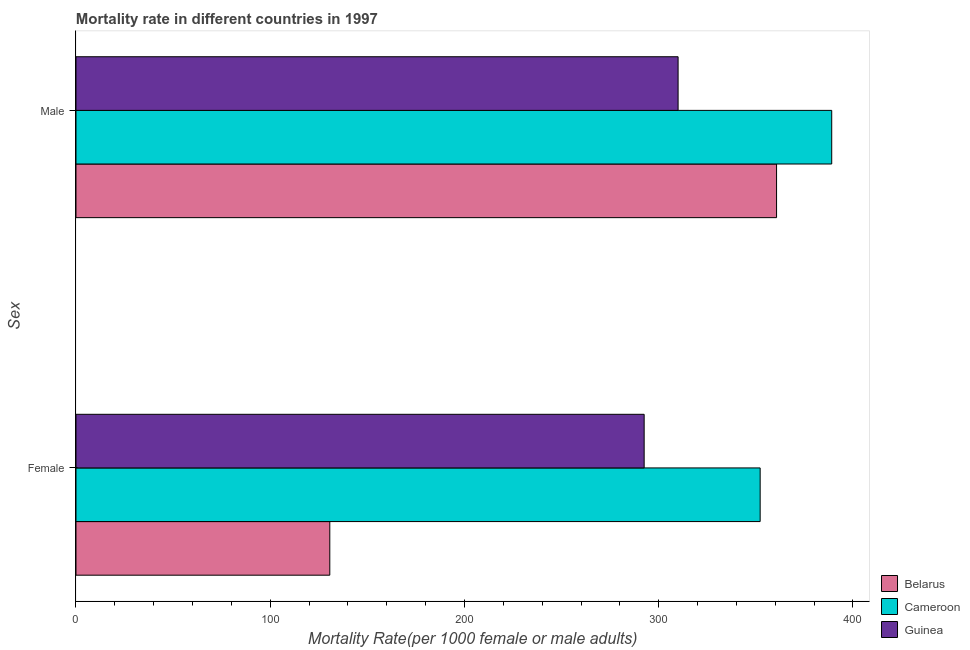How many different coloured bars are there?
Offer a very short reply. 3. Are the number of bars per tick equal to the number of legend labels?
Give a very brief answer. Yes. Are the number of bars on each tick of the Y-axis equal?
Provide a succinct answer. Yes. How many bars are there on the 1st tick from the bottom?
Provide a succinct answer. 3. What is the label of the 1st group of bars from the top?
Your answer should be compact. Male. What is the male mortality rate in Guinea?
Provide a succinct answer. 309.97. Across all countries, what is the maximum male mortality rate?
Give a very brief answer. 389.06. Across all countries, what is the minimum female mortality rate?
Your response must be concise. 130.66. In which country was the female mortality rate maximum?
Your response must be concise. Cameroon. In which country was the male mortality rate minimum?
Your answer should be very brief. Guinea. What is the total female mortality rate in the graph?
Keep it short and to the point. 775.38. What is the difference between the male mortality rate in Guinea and that in Cameroon?
Ensure brevity in your answer.  -79.08. What is the difference between the female mortality rate in Cameroon and the male mortality rate in Guinea?
Provide a succinct answer. 42.25. What is the average male mortality rate per country?
Provide a short and direct response. 353.23. What is the difference between the female mortality rate and male mortality rate in Belarus?
Your response must be concise. -230. What is the ratio of the female mortality rate in Guinea to that in Cameroon?
Keep it short and to the point. 0.83. Is the male mortality rate in Guinea less than that in Cameroon?
Keep it short and to the point. Yes. What does the 1st bar from the top in Female represents?
Provide a succinct answer. Guinea. What does the 1st bar from the bottom in Female represents?
Provide a succinct answer. Belarus. How many bars are there?
Keep it short and to the point. 6. How many countries are there in the graph?
Your answer should be compact. 3. Are the values on the major ticks of X-axis written in scientific E-notation?
Your response must be concise. No. Does the graph contain any zero values?
Your answer should be compact. No. How many legend labels are there?
Your answer should be very brief. 3. How are the legend labels stacked?
Give a very brief answer. Vertical. What is the title of the graph?
Offer a terse response. Mortality rate in different countries in 1997. What is the label or title of the X-axis?
Offer a very short reply. Mortality Rate(per 1000 female or male adults). What is the label or title of the Y-axis?
Ensure brevity in your answer.  Sex. What is the Mortality Rate(per 1000 female or male adults) of Belarus in Female?
Offer a very short reply. 130.66. What is the Mortality Rate(per 1000 female or male adults) of Cameroon in Female?
Offer a terse response. 352.22. What is the Mortality Rate(per 1000 female or male adults) of Guinea in Female?
Provide a succinct answer. 292.5. What is the Mortality Rate(per 1000 female or male adults) in Belarus in Male?
Provide a short and direct response. 360.66. What is the Mortality Rate(per 1000 female or male adults) of Cameroon in Male?
Provide a succinct answer. 389.06. What is the Mortality Rate(per 1000 female or male adults) of Guinea in Male?
Your answer should be compact. 309.97. Across all Sex, what is the maximum Mortality Rate(per 1000 female or male adults) in Belarus?
Make the answer very short. 360.66. Across all Sex, what is the maximum Mortality Rate(per 1000 female or male adults) in Cameroon?
Provide a short and direct response. 389.06. Across all Sex, what is the maximum Mortality Rate(per 1000 female or male adults) of Guinea?
Give a very brief answer. 309.97. Across all Sex, what is the minimum Mortality Rate(per 1000 female or male adults) of Belarus?
Make the answer very short. 130.66. Across all Sex, what is the minimum Mortality Rate(per 1000 female or male adults) of Cameroon?
Your answer should be compact. 352.22. Across all Sex, what is the minimum Mortality Rate(per 1000 female or male adults) in Guinea?
Your answer should be compact. 292.5. What is the total Mortality Rate(per 1000 female or male adults) of Belarus in the graph?
Offer a terse response. 491.33. What is the total Mortality Rate(per 1000 female or male adults) of Cameroon in the graph?
Give a very brief answer. 741.27. What is the total Mortality Rate(per 1000 female or male adults) of Guinea in the graph?
Keep it short and to the point. 602.47. What is the difference between the Mortality Rate(per 1000 female or male adults) of Belarus in Female and that in Male?
Your answer should be very brief. -230. What is the difference between the Mortality Rate(per 1000 female or male adults) of Cameroon in Female and that in Male?
Your answer should be compact. -36.84. What is the difference between the Mortality Rate(per 1000 female or male adults) of Guinea in Female and that in Male?
Your answer should be compact. -17.47. What is the difference between the Mortality Rate(per 1000 female or male adults) of Belarus in Female and the Mortality Rate(per 1000 female or male adults) of Cameroon in Male?
Offer a very short reply. -258.39. What is the difference between the Mortality Rate(per 1000 female or male adults) in Belarus in Female and the Mortality Rate(per 1000 female or male adults) in Guinea in Male?
Provide a succinct answer. -179.31. What is the difference between the Mortality Rate(per 1000 female or male adults) in Cameroon in Female and the Mortality Rate(per 1000 female or male adults) in Guinea in Male?
Offer a terse response. 42.25. What is the average Mortality Rate(per 1000 female or male adults) of Belarus per Sex?
Offer a terse response. 245.66. What is the average Mortality Rate(per 1000 female or male adults) in Cameroon per Sex?
Make the answer very short. 370.64. What is the average Mortality Rate(per 1000 female or male adults) in Guinea per Sex?
Provide a succinct answer. 301.23. What is the difference between the Mortality Rate(per 1000 female or male adults) of Belarus and Mortality Rate(per 1000 female or male adults) of Cameroon in Female?
Make the answer very short. -221.55. What is the difference between the Mortality Rate(per 1000 female or male adults) of Belarus and Mortality Rate(per 1000 female or male adults) of Guinea in Female?
Provide a succinct answer. -161.84. What is the difference between the Mortality Rate(per 1000 female or male adults) in Cameroon and Mortality Rate(per 1000 female or male adults) in Guinea in Female?
Provide a succinct answer. 59.72. What is the difference between the Mortality Rate(per 1000 female or male adults) of Belarus and Mortality Rate(per 1000 female or male adults) of Cameroon in Male?
Offer a very short reply. -28.39. What is the difference between the Mortality Rate(per 1000 female or male adults) of Belarus and Mortality Rate(per 1000 female or male adults) of Guinea in Male?
Ensure brevity in your answer.  50.69. What is the difference between the Mortality Rate(per 1000 female or male adults) in Cameroon and Mortality Rate(per 1000 female or male adults) in Guinea in Male?
Keep it short and to the point. 79.08. What is the ratio of the Mortality Rate(per 1000 female or male adults) of Belarus in Female to that in Male?
Your response must be concise. 0.36. What is the ratio of the Mortality Rate(per 1000 female or male adults) of Cameroon in Female to that in Male?
Offer a terse response. 0.91. What is the ratio of the Mortality Rate(per 1000 female or male adults) in Guinea in Female to that in Male?
Give a very brief answer. 0.94. What is the difference between the highest and the second highest Mortality Rate(per 1000 female or male adults) of Belarus?
Give a very brief answer. 230. What is the difference between the highest and the second highest Mortality Rate(per 1000 female or male adults) in Cameroon?
Your answer should be compact. 36.84. What is the difference between the highest and the second highest Mortality Rate(per 1000 female or male adults) in Guinea?
Offer a terse response. 17.47. What is the difference between the highest and the lowest Mortality Rate(per 1000 female or male adults) in Belarus?
Your response must be concise. 230. What is the difference between the highest and the lowest Mortality Rate(per 1000 female or male adults) of Cameroon?
Provide a succinct answer. 36.84. What is the difference between the highest and the lowest Mortality Rate(per 1000 female or male adults) in Guinea?
Give a very brief answer. 17.47. 